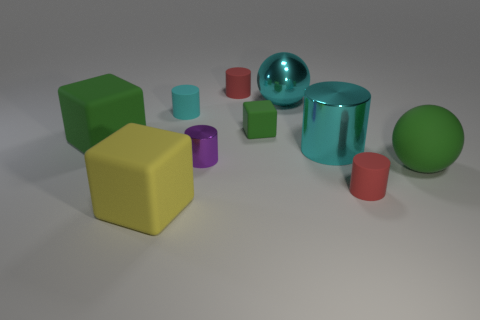What material is the green cube that is the same size as the purple cylinder?
Provide a short and direct response. Rubber. Are there fewer small rubber cylinders behind the small cyan cylinder than large green matte blocks in front of the big yellow matte thing?
Provide a succinct answer. No. There is a red object in front of the large green sphere that is to the right of the big cyan cylinder; what is its shape?
Offer a very short reply. Cylinder. Are any tiny purple metallic cylinders visible?
Ensure brevity in your answer.  Yes. There is a large cube that is left of the large yellow thing; what is its color?
Offer a terse response. Green. There is another block that is the same color as the tiny block; what material is it?
Your answer should be very brief. Rubber. There is a big cyan metal ball; are there any metallic cylinders behind it?
Provide a short and direct response. No. Are there more small purple things than tiny objects?
Ensure brevity in your answer.  No. What color is the metallic object in front of the shiny cylinder on the right side of the green matte block right of the big green rubber cube?
Offer a very short reply. Purple. There is a sphere that is made of the same material as the small block; what color is it?
Your answer should be compact. Green. 